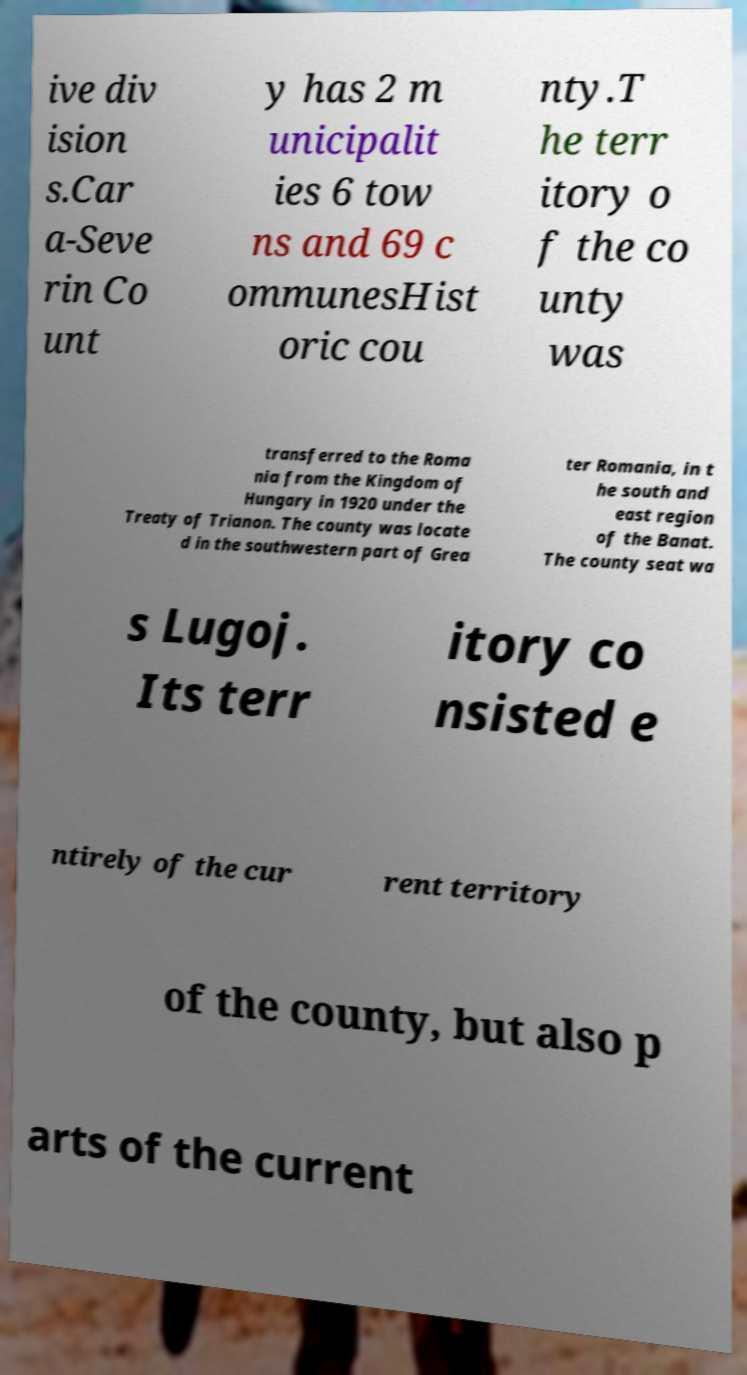What messages or text are displayed in this image? I need them in a readable, typed format. ive div ision s.Car a-Seve rin Co unt y has 2 m unicipalit ies 6 tow ns and 69 c ommunesHist oric cou nty.T he terr itory o f the co unty was transferred to the Roma nia from the Kingdom of Hungary in 1920 under the Treaty of Trianon. The county was locate d in the southwestern part of Grea ter Romania, in t he south and east region of the Banat. The county seat wa s Lugoj. Its terr itory co nsisted e ntirely of the cur rent territory of the county, but also p arts of the current 